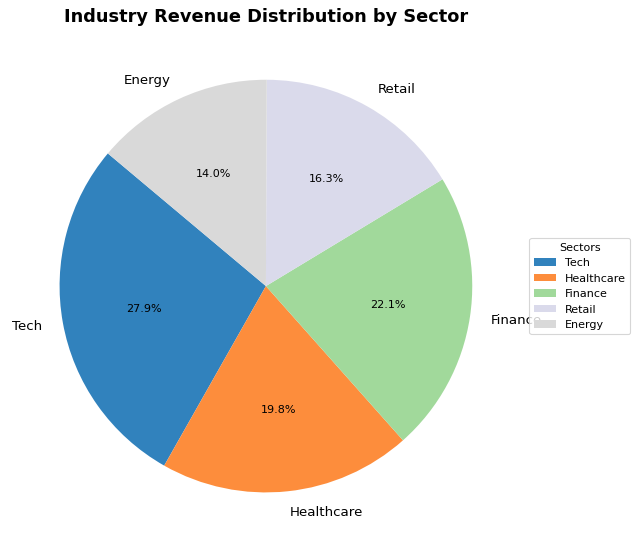What percentage of the revenue is generated by the Tech sector? The Tech sector's revenue is 1200. The total revenue is (1200 + 850 + 950 + 700 + 600) = 4300. The percentage is (1200 / 4300) * 100 ≈ 27.9%.
Answer: 27.9% Which sector generates the least revenue? By comparing the revenue amounts, we see that the Energy sector generates the least revenue at 600.
Answer: Energy What is the combined revenue percentage of the Finance and Retail sectors? The combined revenue of Finance and Retail is (950 + 700) = 1650. The total revenue is 4300. The combined percentage is (1650 / 4300) * 100 ≈ 38.4%.
Answer: 38.4% How does the revenue of the Healthcare sector compare to the Retail sector? The Healthcare sector generates 850, while the Retail sector generates 700. Thus, Healthcare generates more revenue than Retail.
Answer: Healthcare generates more What is the visual color representation of the Tech sector on the pie chart? The pie chart uses color mappings from the tab20c colormap. The Tech sector is typically assigned the first color, which is usually a shade of light blue.
Answer: Light blue If the total revenue increases by 10% while keeping the sector distributions the same, what will be the new revenue for the Tech sector? If the total revenue increases by 10%, the new total revenue is 4300 * 1.10 = 4730. The Tech sector's percentage share remains 1200 / 4300 ≈ 27.9%. So, the new Tech revenue is 27.9% of 4730 ≈ 1320.
Answer: 1320 What percentage of the total revenue is generated by sectors other than Tech and Healthcare? The combined revenue for sectors other than Tech and Healthcare is (950 + 700 + 600) = 2250. The total revenue is 4300. Therefore, the percentage is (2250 / 4300) * 100 ≈ 52.3%.
Answer: 52.3% Which sector is represented closest to a 90-degree segment in the pie chart? Each 90-degree segment represents 25% of the pie chart. By comparing sectors, the Tech sector at 27.9% is closest to the 90-degree segment.
Answer: Tech How many sectors have a revenue percentage lower than 20%? The percentages for sectors are: Tech (27.9%), Healthcare (19.8%), Finance (22.1%), Retail (16.3%), and Energy (14.0%). Only Retail and Energy have percentages lower than 20%.
Answer: 2 